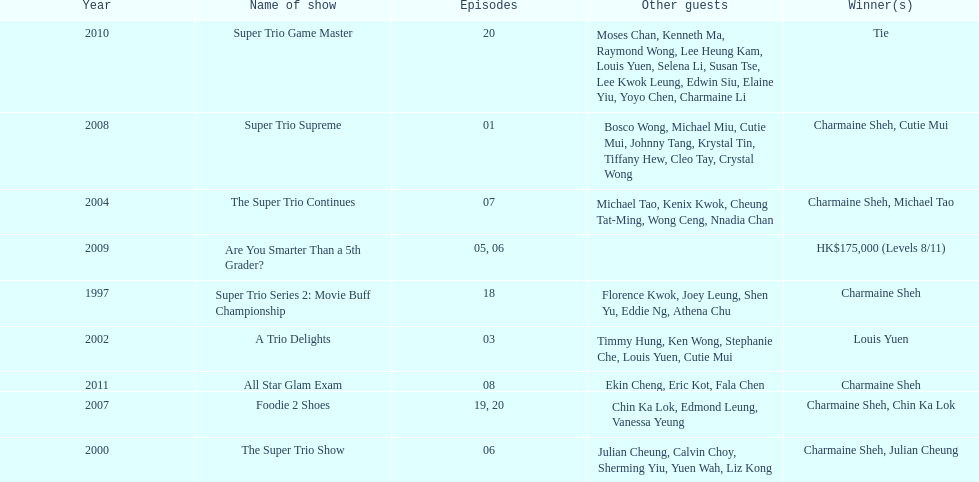How many episodes was charmaine sheh on in the variety show super trio 2: movie buff champions 18. 